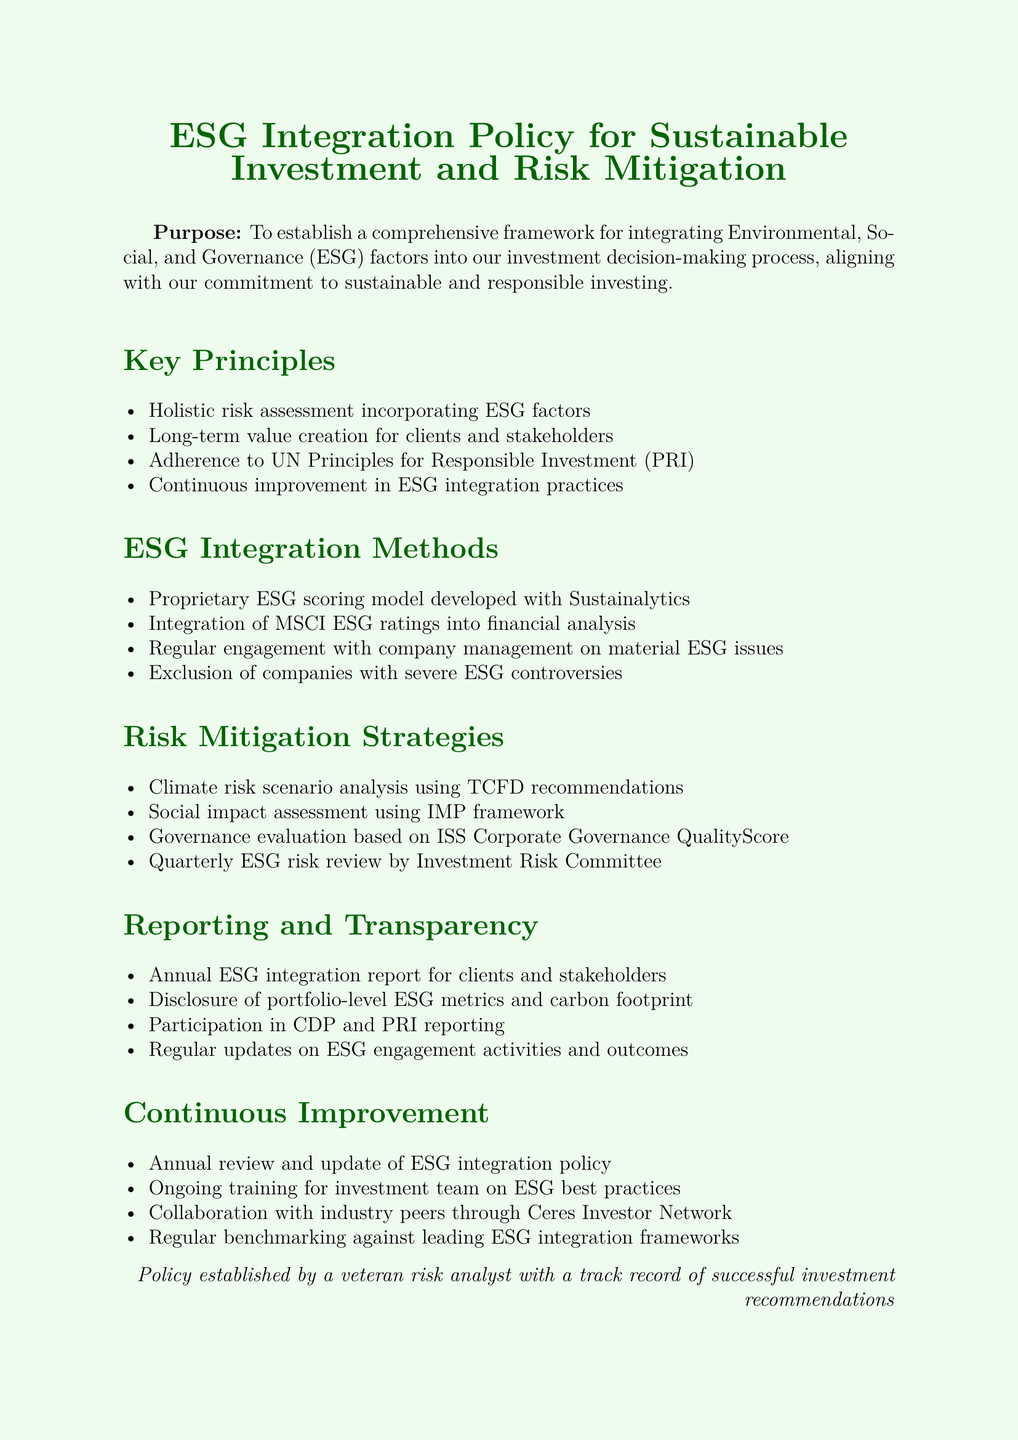What is the purpose of the ESG Integration Policy? The purpose is to establish a comprehensive framework for integrating ESG factors into the investment decision-making process.
Answer: To establish a comprehensive framework for integrating ESG factors What is one method used for ESG integration? The document lists specific methods for ESG integration, including the proprietary ESG scoring model.
Answer: Proprietary ESG scoring model Which framework is used for climate risk scenario analysis? The framework mentioned for climate risk scenario analysis is the TCFD recommendations.
Answer: TCFD recommendations How often is the ESG risk reviewed? The document states that there is a quarterly review by the Investment Risk Committee.
Answer: Quarterly What does the ESG reporting include for clients? The annual ESG integration report includes portfolio-level ESG metrics and carbon footprint disclosure.
Answer: Annual ESG integration report What type of training is provided to the investment team? The document mentions ongoing training for the investment team on ESG best practices.
Answer: ESG best practices Which organizations are mentioned for reporting participation? The document states participation in the CDP and PRI reporting for transparency.
Answer: CDP and PRI What is the frequency of the ESG integration policy review? The document specifies that there is an annual review and update of the policy.
Answer: Annual 